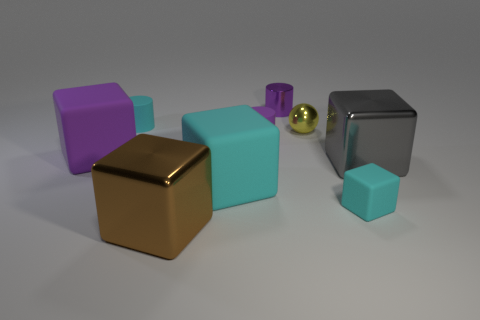Are any cyan cylinders visible?
Your answer should be very brief. Yes. What number of other things are there of the same material as the large gray thing
Your response must be concise. 3. What material is the brown cube that is the same size as the gray thing?
Keep it short and to the point. Metal. There is a shiny thing that is behind the small yellow shiny object; is it the same shape as the yellow object?
Keep it short and to the point. No. Does the tiny rubber cube have the same color as the small shiny ball?
Your response must be concise. No. What number of things are tiny rubber things on the right side of the metallic cylinder or cyan cubes?
Your answer should be very brief. 2. What is the shape of the cyan matte thing that is the same size as the brown metal block?
Provide a succinct answer. Cube. Is the size of the purple cylinder in front of the purple metal thing the same as the purple metal cylinder that is on the left side of the small cube?
Provide a succinct answer. Yes. There is a cylinder that is the same material as the big gray cube; what color is it?
Your response must be concise. Purple. Are the thing in front of the small matte block and the large object behind the large gray metallic cube made of the same material?
Make the answer very short. No. 